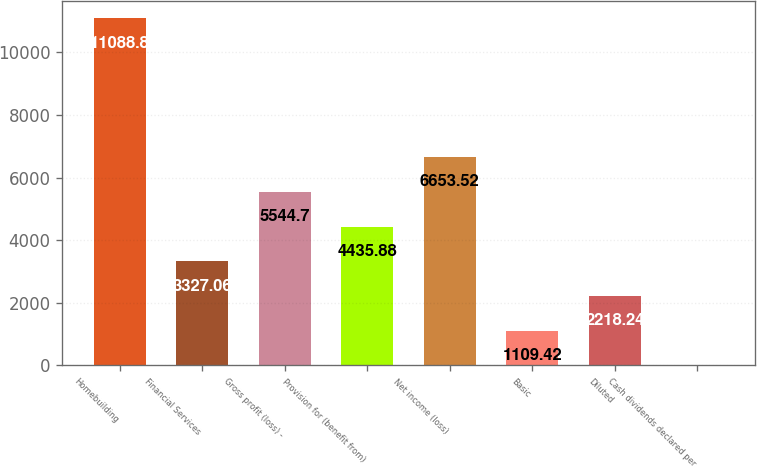Convert chart to OTSL. <chart><loc_0><loc_0><loc_500><loc_500><bar_chart><fcel>Homebuilding<fcel>Financial Services<fcel>Gross profit (loss) -<fcel>Provision for (benefit from)<fcel>Net income (loss)<fcel>Basic<fcel>Diluted<fcel>Cash dividends declared per<nl><fcel>11088.8<fcel>3327.06<fcel>5544.7<fcel>4435.88<fcel>6653.52<fcel>1109.42<fcel>2218.24<fcel>0.6<nl></chart> 